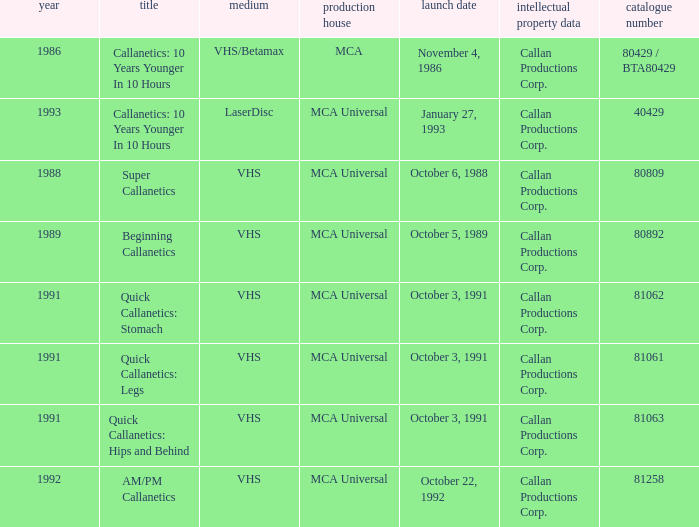Name the format for super callanetics VHS. Parse the full table. {'header': ['year', 'title', 'medium', 'production house', 'launch date', 'intellectual property data', 'catalogue number'], 'rows': [['1986', 'Callanetics: 10 Years Younger In 10 Hours', 'VHS/Betamax', 'MCA', 'November 4, 1986', 'Callan Productions Corp.', '80429 / BTA80429'], ['1993', 'Callanetics: 10 Years Younger In 10 Hours', 'LaserDisc', 'MCA Universal', 'January 27, 1993', 'Callan Productions Corp.', '40429'], ['1988', 'Super Callanetics', 'VHS', 'MCA Universal', 'October 6, 1988', 'Callan Productions Corp.', '80809'], ['1989', 'Beginning Callanetics', 'VHS', 'MCA Universal', 'October 5, 1989', 'Callan Productions Corp.', '80892'], ['1991', 'Quick Callanetics: Stomach', 'VHS', 'MCA Universal', 'October 3, 1991', 'Callan Productions Corp.', '81062'], ['1991', 'Quick Callanetics: Legs', 'VHS', 'MCA Universal', 'October 3, 1991', 'Callan Productions Corp.', '81061'], ['1991', 'Quick Callanetics: Hips and Behind', 'VHS', 'MCA Universal', 'October 3, 1991', 'Callan Productions Corp.', '81063'], ['1992', 'AM/PM Callanetics', 'VHS', 'MCA Universal', 'October 22, 1992', 'Callan Productions Corp.', '81258']]} 